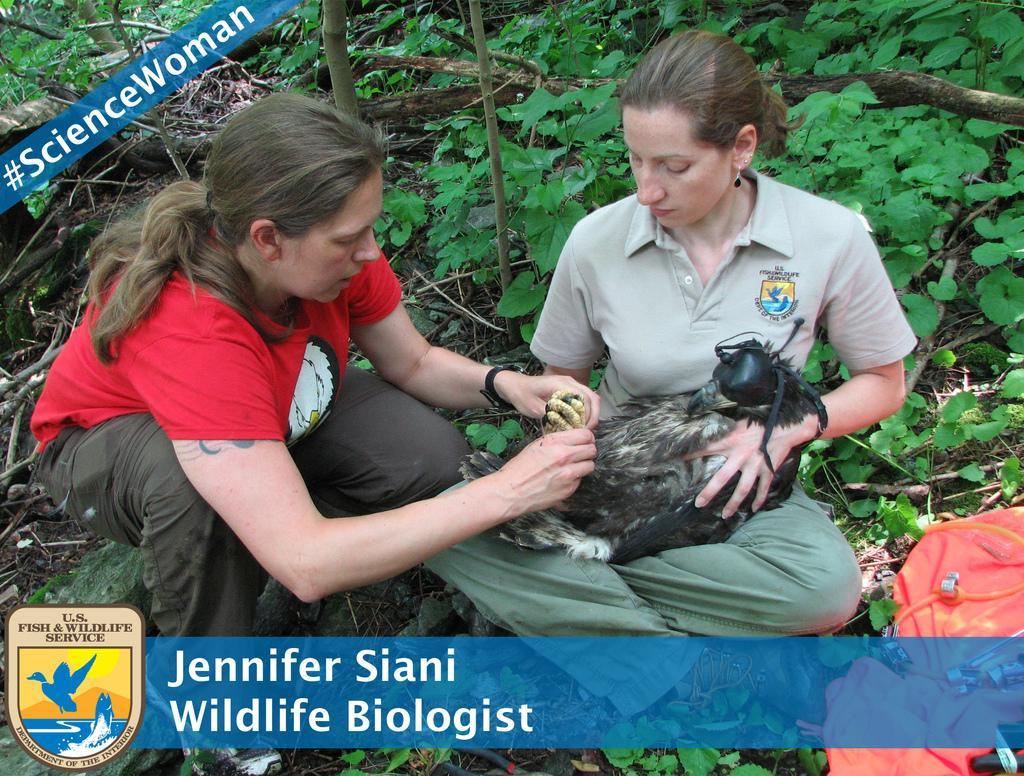Describe this image in one or two sentences. In the foreground of this image, there is a woman sitting on the ground and holding eagle in her lap. Beside her, there is a man squatting and holding the claws of that bird. In the background, there are plants and the sticks. On the right bottom, there is a bag. On the bottom, there is a watermark. 